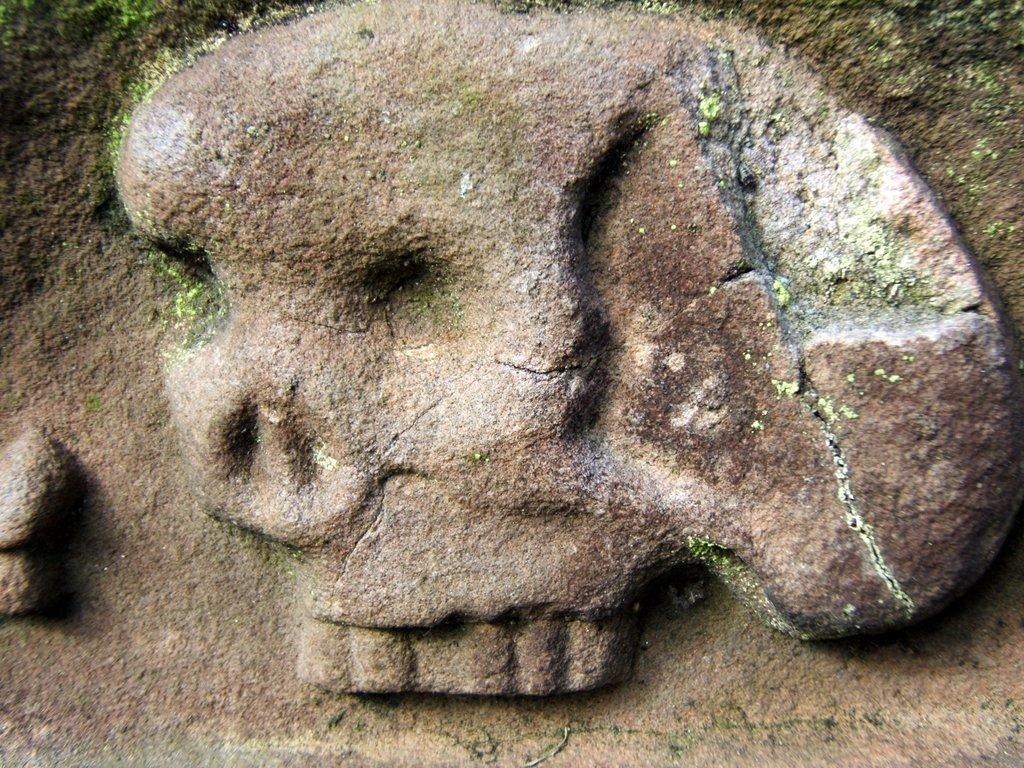Could you give a brief overview of what you see in this image? In this image, we can see rock cut sculpture. 